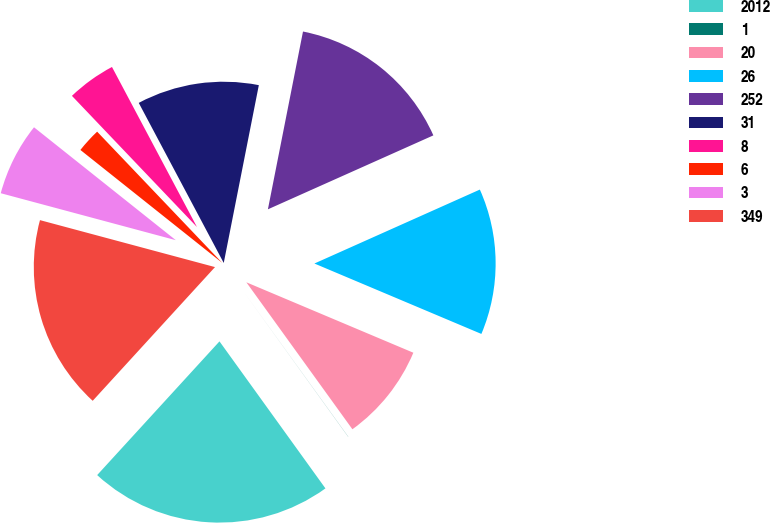Convert chart. <chart><loc_0><loc_0><loc_500><loc_500><pie_chart><fcel>2012<fcel>1<fcel>20<fcel>26<fcel>252<fcel>31<fcel>8<fcel>6<fcel>3<fcel>349<nl><fcel>21.73%<fcel>0.01%<fcel>8.7%<fcel>13.04%<fcel>15.21%<fcel>10.87%<fcel>4.35%<fcel>2.18%<fcel>6.53%<fcel>17.38%<nl></chart> 